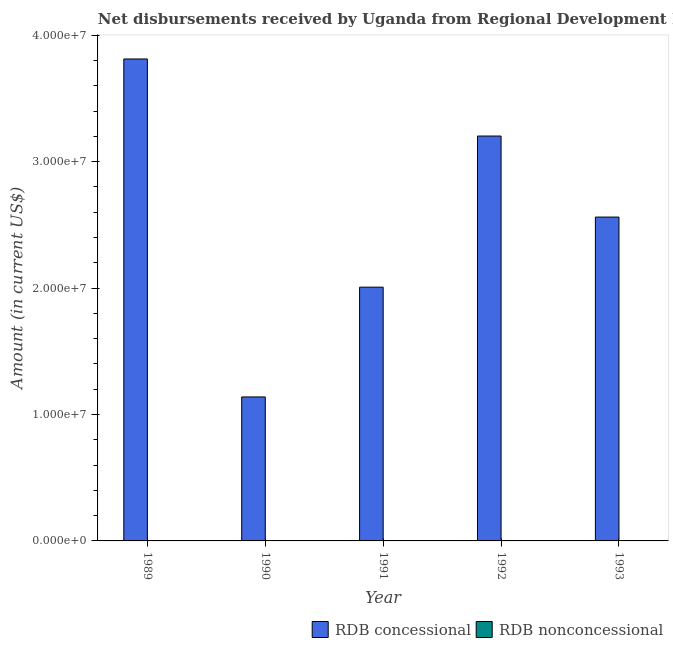How many different coloured bars are there?
Provide a short and direct response. 1. Are the number of bars per tick equal to the number of legend labels?
Your answer should be compact. No. Are the number of bars on each tick of the X-axis equal?
Make the answer very short. Yes. How many bars are there on the 1st tick from the right?
Provide a short and direct response. 1. What is the label of the 2nd group of bars from the left?
Make the answer very short. 1990. In how many cases, is the number of bars for a given year not equal to the number of legend labels?
Provide a short and direct response. 5. What is the net non concessional disbursements from rdb in 1992?
Your answer should be compact. 0. Across all years, what is the maximum net concessional disbursements from rdb?
Your response must be concise. 3.81e+07. Across all years, what is the minimum net non concessional disbursements from rdb?
Give a very brief answer. 0. In which year was the net concessional disbursements from rdb maximum?
Make the answer very short. 1989. What is the total net concessional disbursements from rdb in the graph?
Offer a very short reply. 1.27e+08. What is the difference between the net concessional disbursements from rdb in 1989 and that in 1993?
Provide a short and direct response. 1.25e+07. In the year 1990, what is the difference between the net concessional disbursements from rdb and net non concessional disbursements from rdb?
Make the answer very short. 0. What is the ratio of the net concessional disbursements from rdb in 1989 to that in 1991?
Provide a short and direct response. 1.9. What is the difference between the highest and the second highest net concessional disbursements from rdb?
Offer a terse response. 6.10e+06. What is the difference between the highest and the lowest net concessional disbursements from rdb?
Provide a succinct answer. 2.67e+07. Does the graph contain grids?
Your answer should be very brief. No. Where does the legend appear in the graph?
Give a very brief answer. Bottom right. How many legend labels are there?
Your answer should be very brief. 2. How are the legend labels stacked?
Your answer should be very brief. Horizontal. What is the title of the graph?
Your answer should be compact. Net disbursements received by Uganda from Regional Development Bank. Does "Public funds" appear as one of the legend labels in the graph?
Offer a very short reply. No. What is the label or title of the X-axis?
Provide a succinct answer. Year. What is the Amount (in current US$) of RDB concessional in 1989?
Ensure brevity in your answer.  3.81e+07. What is the Amount (in current US$) of RDB nonconcessional in 1989?
Give a very brief answer. 0. What is the Amount (in current US$) in RDB concessional in 1990?
Keep it short and to the point. 1.14e+07. What is the Amount (in current US$) of RDB nonconcessional in 1990?
Offer a terse response. 0. What is the Amount (in current US$) in RDB concessional in 1991?
Ensure brevity in your answer.  2.01e+07. What is the Amount (in current US$) in RDB nonconcessional in 1991?
Your answer should be compact. 0. What is the Amount (in current US$) of RDB concessional in 1992?
Your answer should be very brief. 3.20e+07. What is the Amount (in current US$) in RDB concessional in 1993?
Offer a terse response. 2.56e+07. What is the Amount (in current US$) of RDB nonconcessional in 1993?
Give a very brief answer. 0. Across all years, what is the maximum Amount (in current US$) of RDB concessional?
Provide a succinct answer. 3.81e+07. Across all years, what is the minimum Amount (in current US$) of RDB concessional?
Keep it short and to the point. 1.14e+07. What is the total Amount (in current US$) of RDB concessional in the graph?
Offer a terse response. 1.27e+08. What is the total Amount (in current US$) in RDB nonconcessional in the graph?
Offer a very short reply. 0. What is the difference between the Amount (in current US$) in RDB concessional in 1989 and that in 1990?
Make the answer very short. 2.67e+07. What is the difference between the Amount (in current US$) of RDB concessional in 1989 and that in 1991?
Give a very brief answer. 1.81e+07. What is the difference between the Amount (in current US$) in RDB concessional in 1989 and that in 1992?
Offer a very short reply. 6.10e+06. What is the difference between the Amount (in current US$) in RDB concessional in 1989 and that in 1993?
Your answer should be compact. 1.25e+07. What is the difference between the Amount (in current US$) of RDB concessional in 1990 and that in 1991?
Provide a short and direct response. -8.68e+06. What is the difference between the Amount (in current US$) in RDB concessional in 1990 and that in 1992?
Provide a succinct answer. -2.06e+07. What is the difference between the Amount (in current US$) of RDB concessional in 1990 and that in 1993?
Offer a very short reply. -1.42e+07. What is the difference between the Amount (in current US$) in RDB concessional in 1991 and that in 1992?
Provide a succinct answer. -1.20e+07. What is the difference between the Amount (in current US$) of RDB concessional in 1991 and that in 1993?
Provide a short and direct response. -5.54e+06. What is the difference between the Amount (in current US$) in RDB concessional in 1992 and that in 1993?
Make the answer very short. 6.41e+06. What is the average Amount (in current US$) of RDB concessional per year?
Keep it short and to the point. 2.54e+07. What is the average Amount (in current US$) of RDB nonconcessional per year?
Your response must be concise. 0. What is the ratio of the Amount (in current US$) in RDB concessional in 1989 to that in 1990?
Provide a succinct answer. 3.35. What is the ratio of the Amount (in current US$) in RDB concessional in 1989 to that in 1991?
Provide a succinct answer. 1.9. What is the ratio of the Amount (in current US$) of RDB concessional in 1989 to that in 1992?
Ensure brevity in your answer.  1.19. What is the ratio of the Amount (in current US$) of RDB concessional in 1989 to that in 1993?
Make the answer very short. 1.49. What is the ratio of the Amount (in current US$) in RDB concessional in 1990 to that in 1991?
Offer a terse response. 0.57. What is the ratio of the Amount (in current US$) of RDB concessional in 1990 to that in 1992?
Make the answer very short. 0.36. What is the ratio of the Amount (in current US$) in RDB concessional in 1990 to that in 1993?
Provide a succinct answer. 0.44. What is the ratio of the Amount (in current US$) in RDB concessional in 1991 to that in 1992?
Your response must be concise. 0.63. What is the ratio of the Amount (in current US$) in RDB concessional in 1991 to that in 1993?
Ensure brevity in your answer.  0.78. What is the ratio of the Amount (in current US$) of RDB concessional in 1992 to that in 1993?
Provide a short and direct response. 1.25. What is the difference between the highest and the second highest Amount (in current US$) in RDB concessional?
Offer a terse response. 6.10e+06. What is the difference between the highest and the lowest Amount (in current US$) in RDB concessional?
Provide a succinct answer. 2.67e+07. 